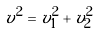Convert formula to latex. <formula><loc_0><loc_0><loc_500><loc_500>v ^ { 2 } = v _ { 1 } ^ { 2 } + v _ { 2 } ^ { 2 }</formula> 